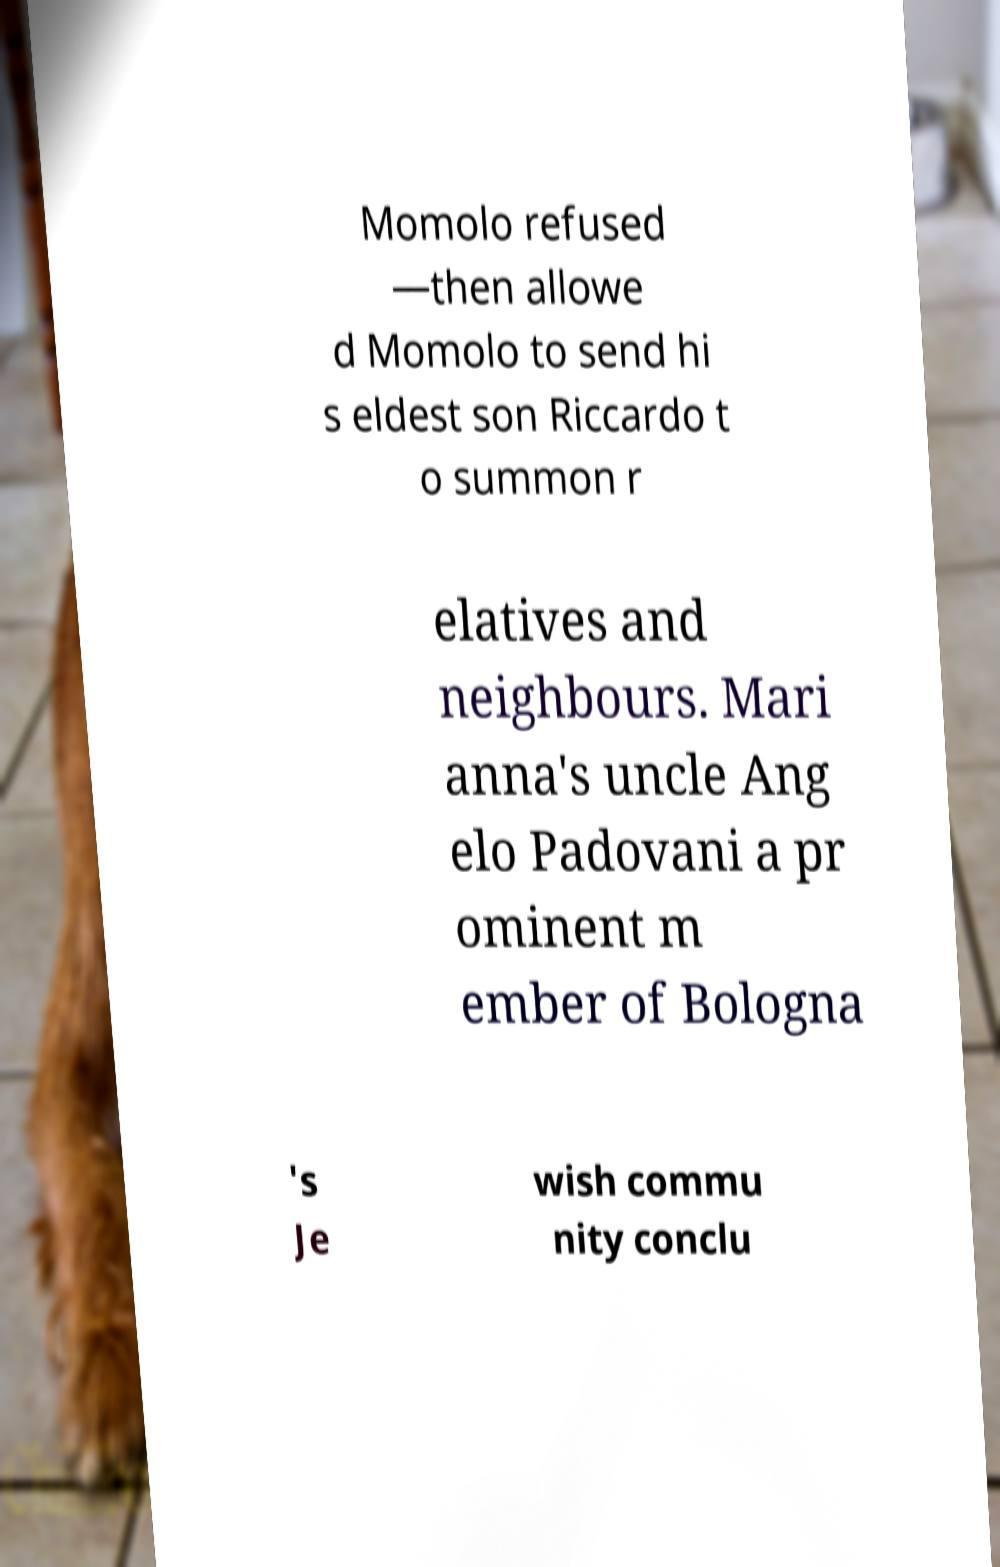Could you assist in decoding the text presented in this image and type it out clearly? Momolo refused —then allowe d Momolo to send hi s eldest son Riccardo t o summon r elatives and neighbours. Mari anna's uncle Ang elo Padovani a pr ominent m ember of Bologna 's Je wish commu nity conclu 